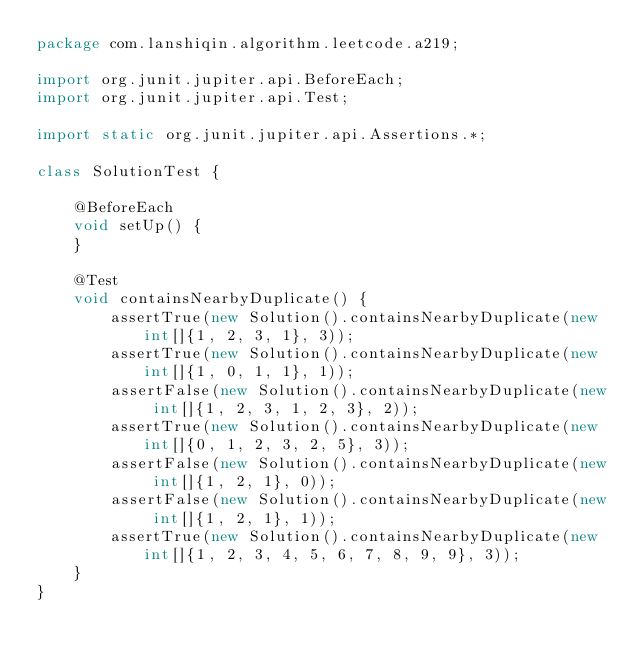Convert code to text. <code><loc_0><loc_0><loc_500><loc_500><_Java_>package com.lanshiqin.algorithm.leetcode.a219;

import org.junit.jupiter.api.BeforeEach;
import org.junit.jupiter.api.Test;

import static org.junit.jupiter.api.Assertions.*;

class SolutionTest {

    @BeforeEach
    void setUp() {
    }

    @Test
    void containsNearbyDuplicate() {
        assertTrue(new Solution().containsNearbyDuplicate(new int[]{1, 2, 3, 1}, 3));
        assertTrue(new Solution().containsNearbyDuplicate(new int[]{1, 0, 1, 1}, 1));
        assertFalse(new Solution().containsNearbyDuplicate(new int[]{1, 2, 3, 1, 2, 3}, 2));
        assertTrue(new Solution().containsNearbyDuplicate(new int[]{0, 1, 2, 3, 2, 5}, 3));
        assertFalse(new Solution().containsNearbyDuplicate(new int[]{1, 2, 1}, 0));
        assertFalse(new Solution().containsNearbyDuplicate(new int[]{1, 2, 1}, 1));
        assertTrue(new Solution().containsNearbyDuplicate(new int[]{1, 2, 3, 4, 5, 6, 7, 8, 9, 9}, 3));
    }
}</code> 